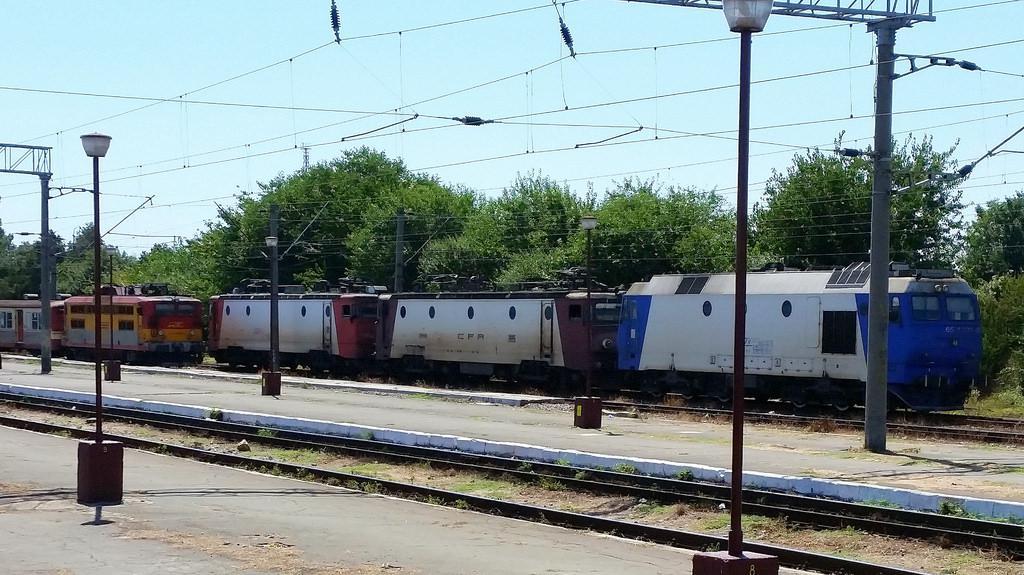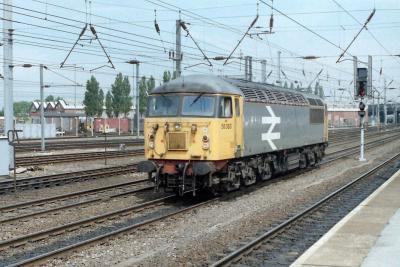The first image is the image on the left, the second image is the image on the right. Examine the images to the left and right. Is the description "The right image shows a train with the front car colored red and yellow." accurate? Answer yes or no. No. 